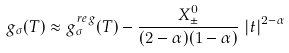Convert formula to latex. <formula><loc_0><loc_0><loc_500><loc_500>g _ { \sigma } ( T ) \approx g ^ { r e g } _ { \sigma } ( T ) - \frac { X ^ { 0 } _ { \pm } } { ( 2 - \alpha ) ( 1 - \alpha ) } \, \left | { t } \right | ^ { 2 - \alpha }</formula> 